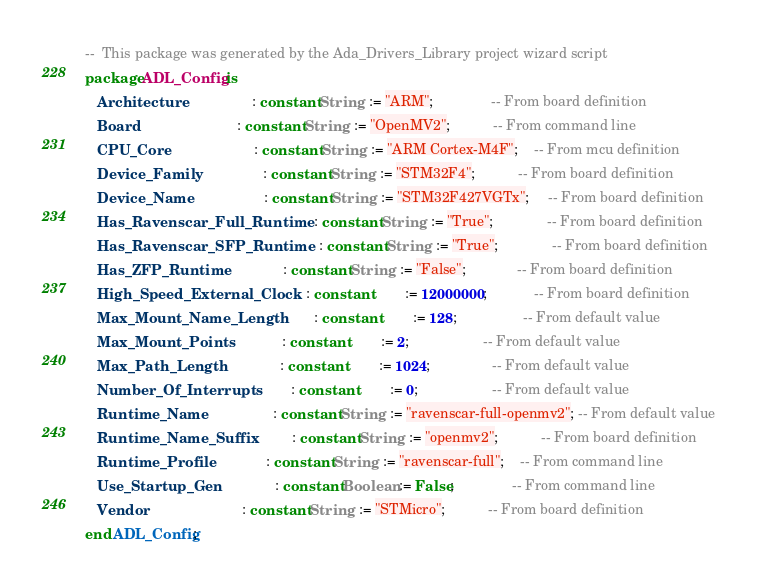<code> <loc_0><loc_0><loc_500><loc_500><_Ada_>--  This package was generated by the Ada_Drivers_Library project wizard script
package ADL_Config is
   Architecture                   : constant String  := "ARM";               -- From board definition
   Board                          : constant String  := "OpenMV2";           -- From command line
   CPU_Core                       : constant String  := "ARM Cortex-M4F";    -- From mcu definition
   Device_Family                  : constant String  := "STM32F4";           -- From board definition
   Device_Name                    : constant String  := "STM32F427VGTx";     -- From board definition
   Has_Ravenscar_Full_Runtime     : constant String  := "True";              -- From board definition
   Has_Ravenscar_SFP_Runtime      : constant String  := "True";              -- From board definition
   Has_ZFP_Runtime                : constant String  := "False";             -- From board definition
   High_Speed_External_Clock      : constant         := 12000000;            -- From board definition
   Max_Mount_Name_Length          : constant         := 128;                 -- From default value
   Max_Mount_Points               : constant         := 2;                   -- From default value
   Max_Path_Length                : constant         := 1024;                -- From default value
   Number_Of_Interrupts           : constant         := 0;                   -- From default value
   Runtime_Name                   : constant String  := "ravenscar-full-openmv2"; -- From default value
   Runtime_Name_Suffix            : constant String  := "openmv2";           -- From board definition
   Runtime_Profile                : constant String  := "ravenscar-full";    -- From command line
   Use_Startup_Gen                : constant Boolean := False;               -- From command line
   Vendor                         : constant String  := "STMicro";           -- From board definition
end ADL_Config;
</code> 